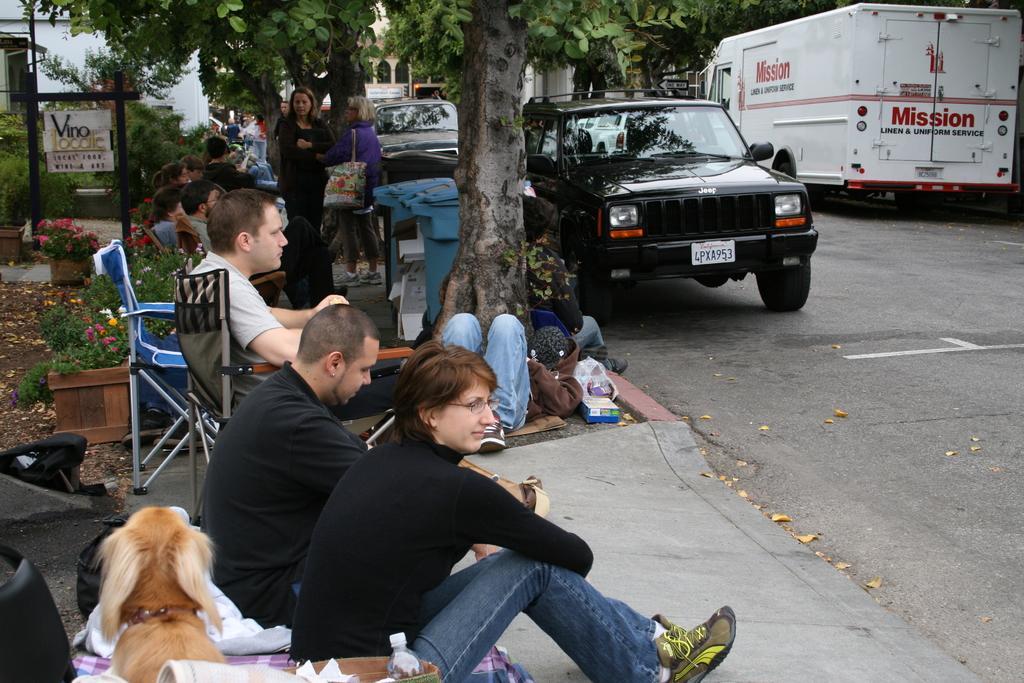Can you describe this image briefly? In the picture there are few people towards the left side of the road and some of them are sitting and there is a dog behind one person and on the right side there are few trees. Beside those trees there are few vehicles on the road, there is some board kept on the left side with the support of poles, around that board there are beautiful flower plants. 